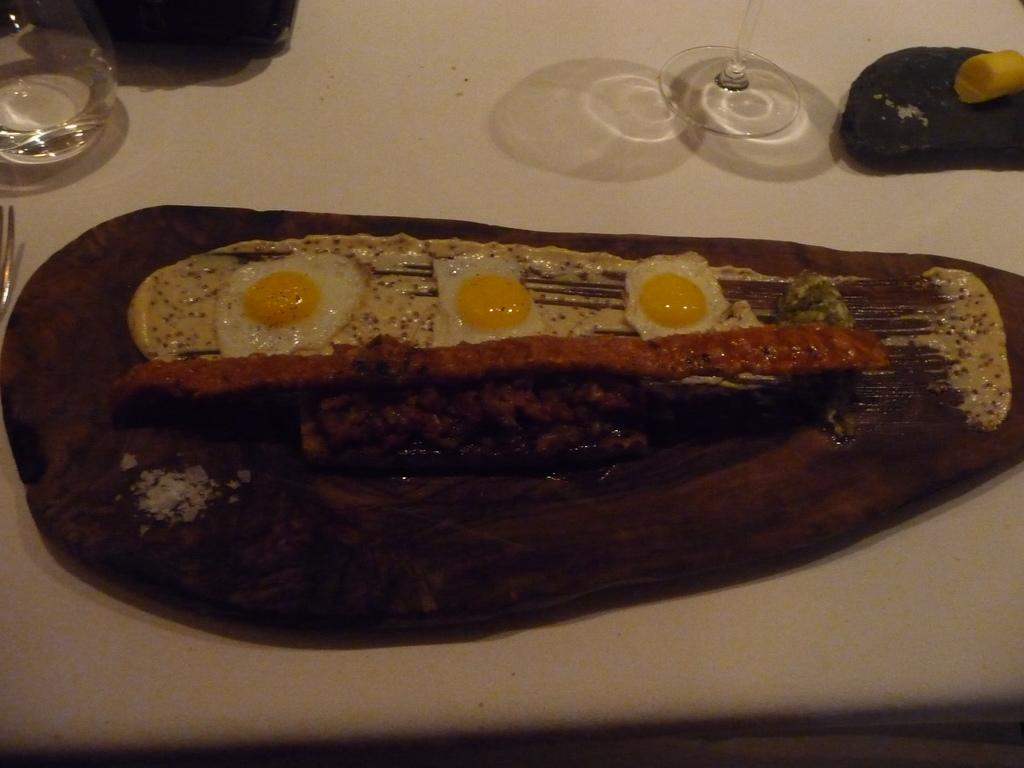What type of surface are the food items placed on in the image? The food items are placed on a wooden surface in the image. What can be seen on the table in the image? There are glasses and a spoon on the table in the image. What is the color of the table in the image? The table in the image is white. How many snakes are slithering on the table in the image? There are no snakes present in the image; it features food items, glasses, and a spoon on a table. What type of bedding is visible in the image? There is no bedding present in the image; it features a table with food items, glasses, and a spoon on a white table. 